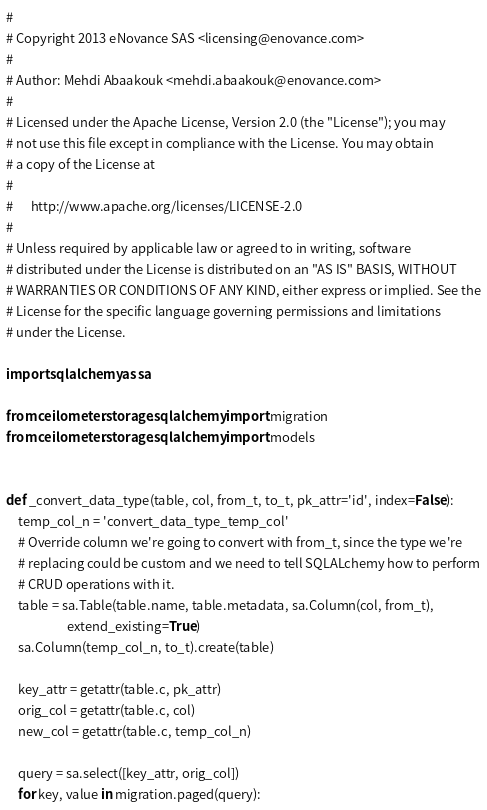<code> <loc_0><loc_0><loc_500><loc_500><_Python_>#
# Copyright 2013 eNovance SAS <licensing@enovance.com>
#
# Author: Mehdi Abaakouk <mehdi.abaakouk@enovance.com>
#
# Licensed under the Apache License, Version 2.0 (the "License"); you may
# not use this file except in compliance with the License. You may obtain
# a copy of the License at
#
#      http://www.apache.org/licenses/LICENSE-2.0
#
# Unless required by applicable law or agreed to in writing, software
# distributed under the License is distributed on an "AS IS" BASIS, WITHOUT
# WARRANTIES OR CONDITIONS OF ANY KIND, either express or implied. See the
# License for the specific language governing permissions and limitations
# under the License.

import sqlalchemy as sa

from ceilometer.storage.sqlalchemy import migration
from ceilometer.storage.sqlalchemy import models


def _convert_data_type(table, col, from_t, to_t, pk_attr='id', index=False):
    temp_col_n = 'convert_data_type_temp_col'
    # Override column we're going to convert with from_t, since the type we're
    # replacing could be custom and we need to tell SQLALchemy how to perform
    # CRUD operations with it.
    table = sa.Table(table.name, table.metadata, sa.Column(col, from_t),
                     extend_existing=True)
    sa.Column(temp_col_n, to_t).create(table)

    key_attr = getattr(table.c, pk_attr)
    orig_col = getattr(table.c, col)
    new_col = getattr(table.c, temp_col_n)

    query = sa.select([key_attr, orig_col])
    for key, value in migration.paged(query):</code> 